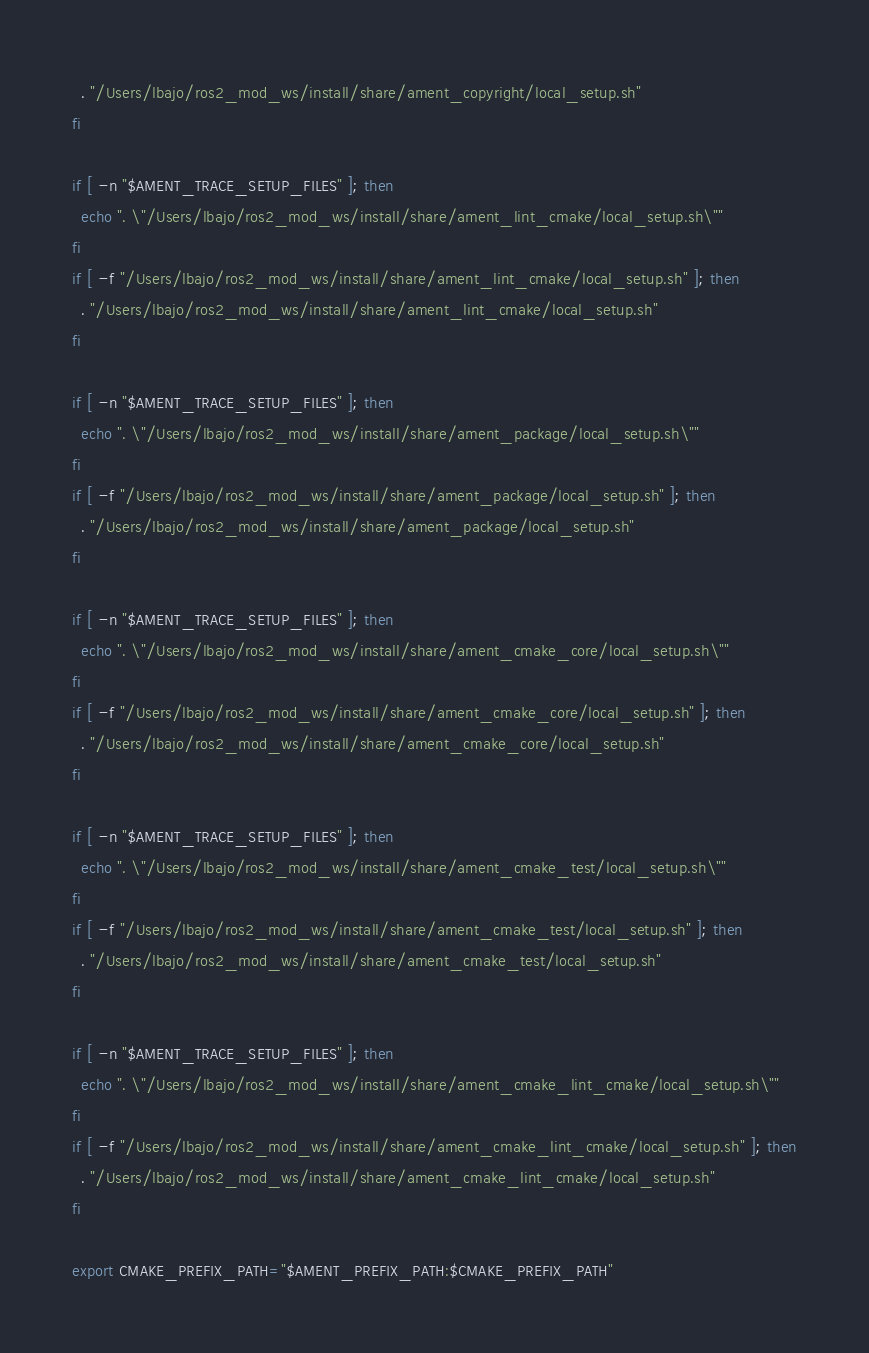<code> <loc_0><loc_0><loc_500><loc_500><_Bash_>  . "/Users/lbajo/ros2_mod_ws/install/share/ament_copyright/local_setup.sh"
fi

if [ -n "$AMENT_TRACE_SETUP_FILES" ]; then
  echo ". \"/Users/lbajo/ros2_mod_ws/install/share/ament_lint_cmake/local_setup.sh\""
fi
if [ -f "/Users/lbajo/ros2_mod_ws/install/share/ament_lint_cmake/local_setup.sh" ]; then
  . "/Users/lbajo/ros2_mod_ws/install/share/ament_lint_cmake/local_setup.sh"
fi

if [ -n "$AMENT_TRACE_SETUP_FILES" ]; then
  echo ". \"/Users/lbajo/ros2_mod_ws/install/share/ament_package/local_setup.sh\""
fi
if [ -f "/Users/lbajo/ros2_mod_ws/install/share/ament_package/local_setup.sh" ]; then
  . "/Users/lbajo/ros2_mod_ws/install/share/ament_package/local_setup.sh"
fi

if [ -n "$AMENT_TRACE_SETUP_FILES" ]; then
  echo ". \"/Users/lbajo/ros2_mod_ws/install/share/ament_cmake_core/local_setup.sh\""
fi
if [ -f "/Users/lbajo/ros2_mod_ws/install/share/ament_cmake_core/local_setup.sh" ]; then
  . "/Users/lbajo/ros2_mod_ws/install/share/ament_cmake_core/local_setup.sh"
fi

if [ -n "$AMENT_TRACE_SETUP_FILES" ]; then
  echo ". \"/Users/lbajo/ros2_mod_ws/install/share/ament_cmake_test/local_setup.sh\""
fi
if [ -f "/Users/lbajo/ros2_mod_ws/install/share/ament_cmake_test/local_setup.sh" ]; then
  . "/Users/lbajo/ros2_mod_ws/install/share/ament_cmake_test/local_setup.sh"
fi

if [ -n "$AMENT_TRACE_SETUP_FILES" ]; then
  echo ". \"/Users/lbajo/ros2_mod_ws/install/share/ament_cmake_lint_cmake/local_setup.sh\""
fi
if [ -f "/Users/lbajo/ros2_mod_ws/install/share/ament_cmake_lint_cmake/local_setup.sh" ]; then
  . "/Users/lbajo/ros2_mod_ws/install/share/ament_cmake_lint_cmake/local_setup.sh"
fi

export CMAKE_PREFIX_PATH="$AMENT_PREFIX_PATH:$CMAKE_PREFIX_PATH"
</code> 